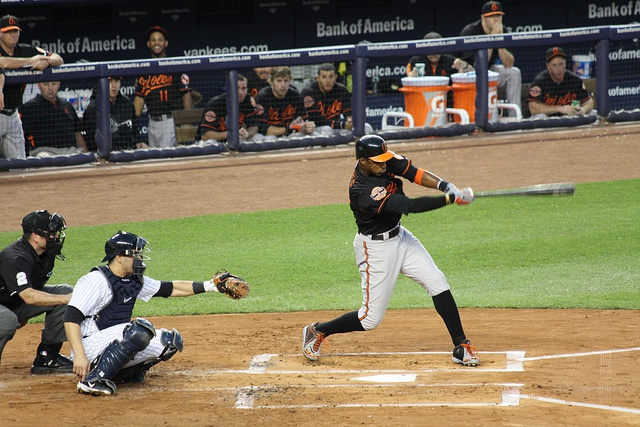Describe the objects in this image and their specific colors. I can see people in black, lightgray, darkgray, and tan tones, people in black, white, and gray tones, people in black, gray, and tan tones, people in black, gray, darkgray, and maroon tones, and people in black, darkgray, and gray tones in this image. 